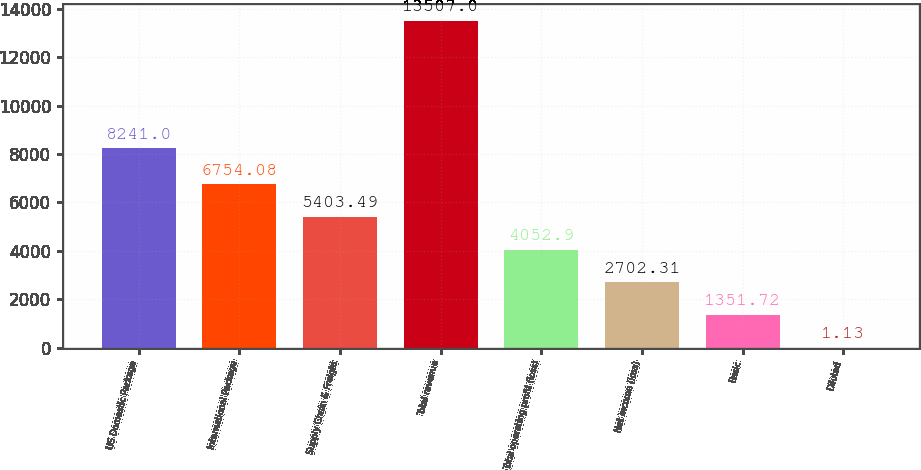Convert chart to OTSL. <chart><loc_0><loc_0><loc_500><loc_500><bar_chart><fcel>US Domestic Package<fcel>International Package<fcel>Supply Chain & Freight<fcel>Total revenue<fcel>Total operating profit (loss)<fcel>Net income (loss)<fcel>Basic<fcel>Diluted<nl><fcel>8241<fcel>6754.08<fcel>5403.49<fcel>13507<fcel>4052.9<fcel>2702.31<fcel>1351.72<fcel>1.13<nl></chart> 